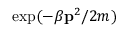<formula> <loc_0><loc_0><loc_500><loc_500>\exp ( - \beta p ^ { 2 } / 2 m )</formula> 